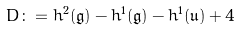<formula> <loc_0><loc_0><loc_500><loc_500>D \colon = h ^ { 2 } ( \mathfrak { g } ) - h ^ { 1 } ( \mathfrak { g } ) - h ^ { 1 } ( \mathfrak { u } ) + 4</formula> 